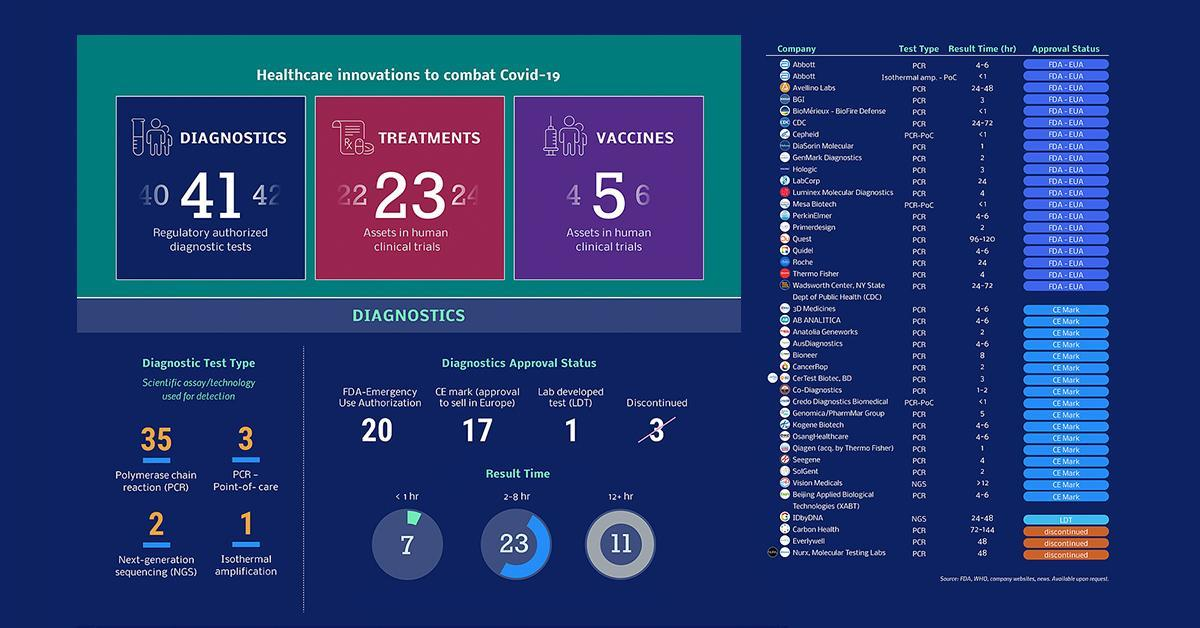The tests conducted by which three companies were discontinued?
Answer the question with a short phrase. Carbon Health, Everlywell, Nurx Molecular testing labs Which company conducts both PCR and isothermal amplification tests? Abbott How many treatments have been developed? 23 How many tests give result in less than 1 hour? 7 How many diagnostic tests have received the FDA-emergency use authorisation? 20 How many regulatory authorised diagnostic tests introduced? 41 How many are lab developed tests? 1 How many diagnostic tests have received the CE mark? 17 How many vaccines have been developed? 5 How many diagnostic tests are of the test type NGS? 2 Which is the diagnostic test type conducted by a majority of the companies? PCR How many tests give the result in 2- 8 hours? 23 Out of the 41 diagnostic tests, how many are isothermal amplification? 1 How many diagnostic approval tests have been discontinued? 3 How many tests take more than 12 hours to give the result? 11 Out of the 41 diagnostic tests, under which test type do majority of the tests fall? Polymerase chain reaction (PCR) What is the result time taken by majority of the diagnostic tests? 2-8 hr Which are the three companies conducting PCR-PoC tests? Cepheid, Mesa Biotech, Credo Diagnostics Biomedical 